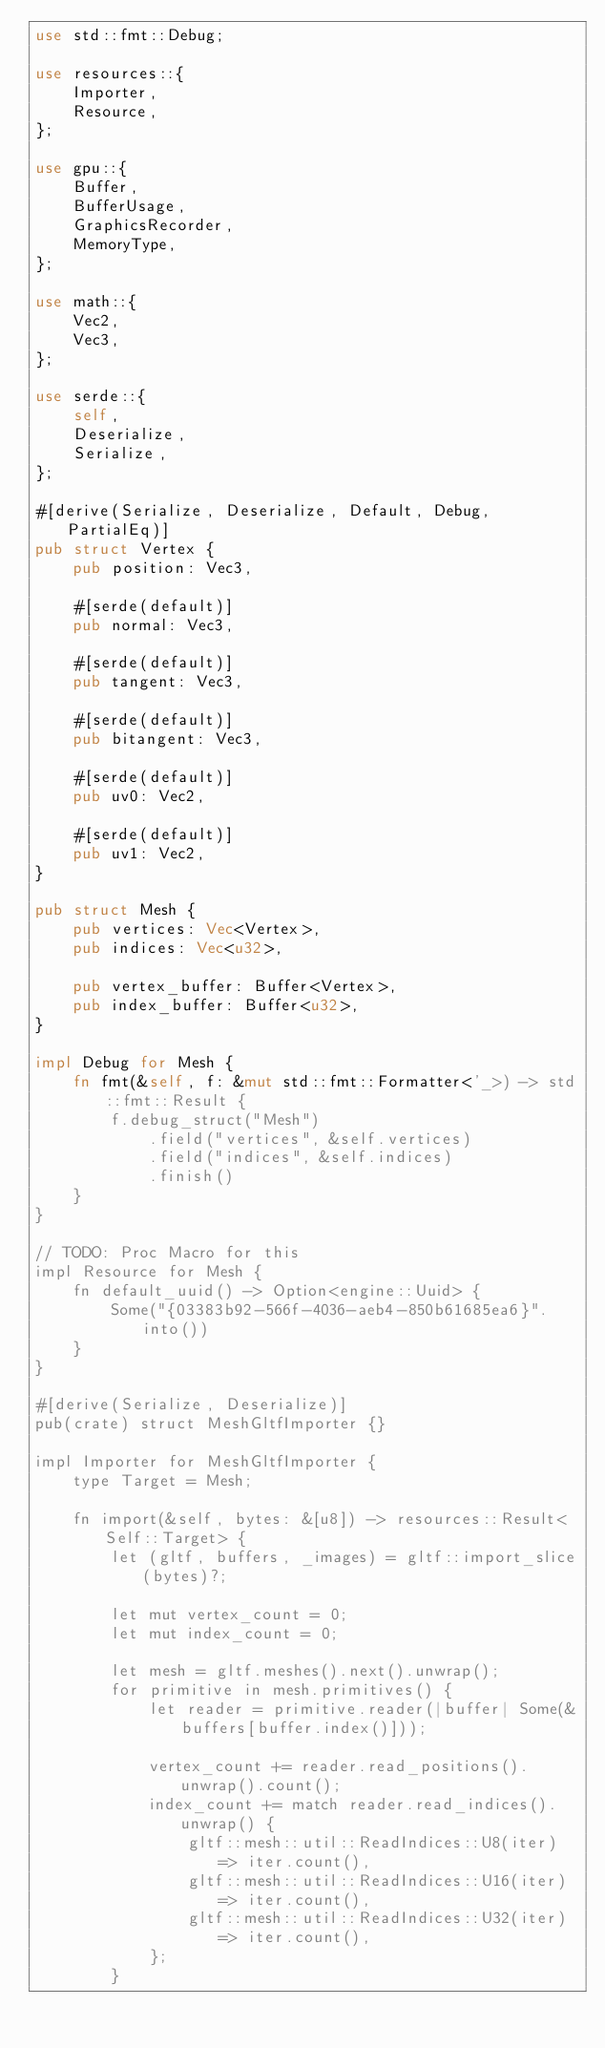Convert code to text. <code><loc_0><loc_0><loc_500><loc_500><_Rust_>use std::fmt::Debug;

use resources::{
	Importer,
	Resource,
};

use gpu::{
	Buffer,
	BufferUsage,
	GraphicsRecorder,
	MemoryType,
};

use math::{
	Vec2,
	Vec3,
};

use serde::{
	self,
	Deserialize,
	Serialize,
};

#[derive(Serialize, Deserialize, Default, Debug, PartialEq)]
pub struct Vertex {
	pub position: Vec3,

	#[serde(default)]
	pub normal: Vec3,

	#[serde(default)]
	pub tangent: Vec3,

	#[serde(default)]
	pub bitangent: Vec3,

	#[serde(default)]
	pub uv0: Vec2,

	#[serde(default)]
	pub uv1: Vec2,
}

pub struct Mesh {
	pub vertices: Vec<Vertex>,
	pub indices: Vec<u32>,

	pub vertex_buffer: Buffer<Vertex>,
	pub index_buffer: Buffer<u32>,
}

impl Debug for Mesh {
	fn fmt(&self, f: &mut std::fmt::Formatter<'_>) -> std::fmt::Result {
		f.debug_struct("Mesh")
			.field("vertices", &self.vertices)
			.field("indices", &self.indices)
			.finish()
	}
}

// TODO: Proc Macro for this
impl Resource for Mesh {
	fn default_uuid() -> Option<engine::Uuid> {
		Some("{03383b92-566f-4036-aeb4-850b61685ea6}".into())
	}
}

#[derive(Serialize, Deserialize)]
pub(crate) struct MeshGltfImporter {}

impl Importer for MeshGltfImporter {
	type Target = Mesh;

	fn import(&self, bytes: &[u8]) -> resources::Result<Self::Target> {
		let (gltf, buffers, _images) = gltf::import_slice(bytes)?;

		let mut vertex_count = 0;
		let mut index_count = 0;

		let mesh = gltf.meshes().next().unwrap();
		for primitive in mesh.primitives() {
			let reader = primitive.reader(|buffer| Some(&buffers[buffer.index()]));

			vertex_count += reader.read_positions().unwrap().count();
			index_count += match reader.read_indices().unwrap() {
				gltf::mesh::util::ReadIndices::U8(iter) => iter.count(),
				gltf::mesh::util::ReadIndices::U16(iter) => iter.count(),
				gltf::mesh::util::ReadIndices::U32(iter) => iter.count(),
			};
		}
</code> 